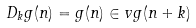<formula> <loc_0><loc_0><loc_500><loc_500>D _ { k } g ( n ) = g ( n ) \in v g ( n + k )</formula> 